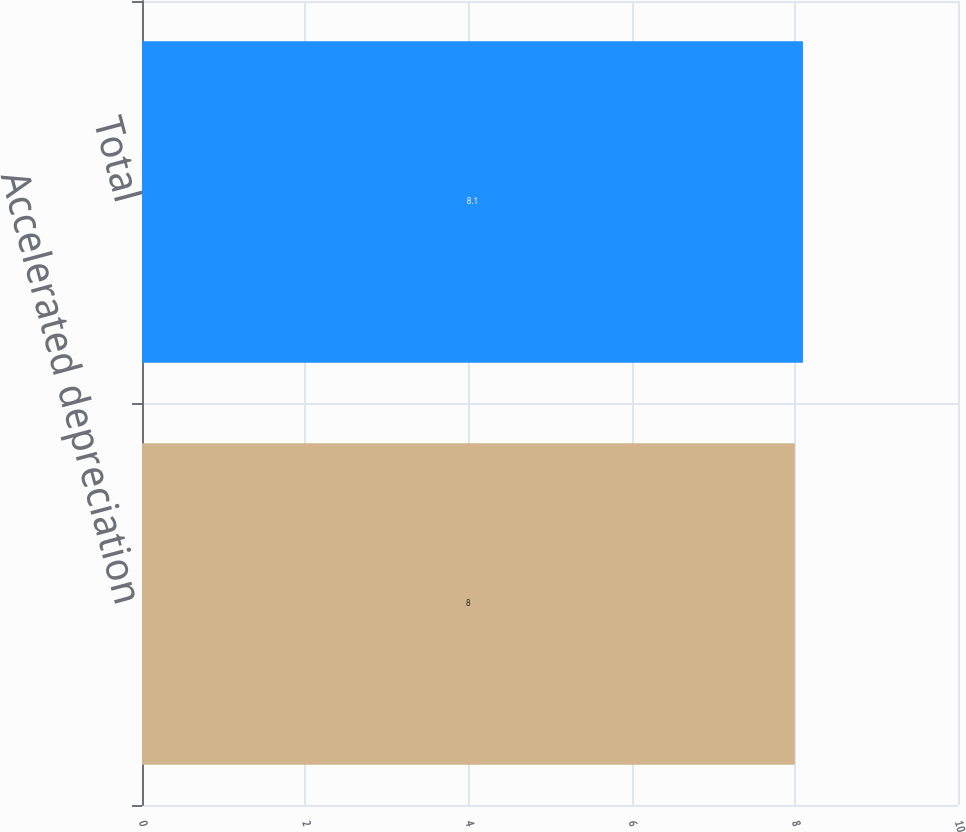<chart> <loc_0><loc_0><loc_500><loc_500><bar_chart><fcel>Accelerated depreciation<fcel>Total<nl><fcel>8<fcel>8.1<nl></chart> 